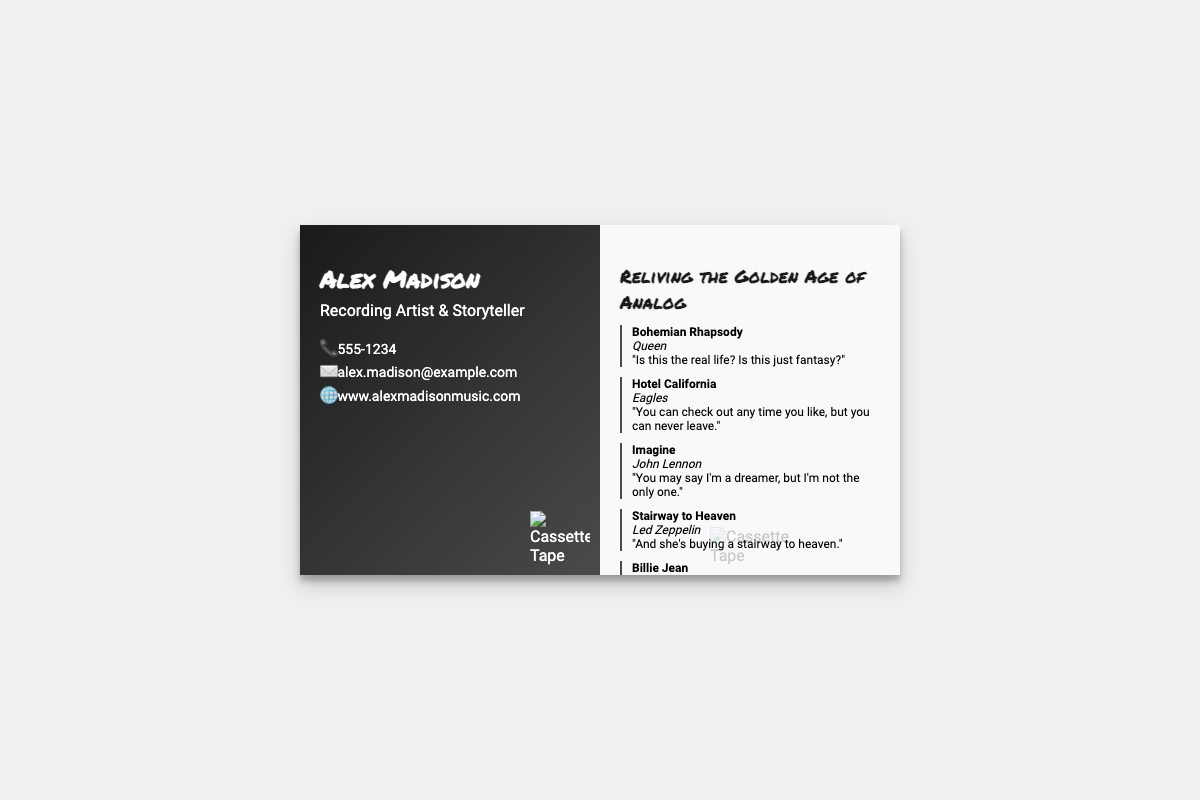What is the name of the recording artist? The name of the recording artist is prominently displayed at the top of the card.
Answer: Alex Madison What is the phone number listed on the business card? The phone number is provided in the contact information section of the card.
Answer: 555-1234 Which song by Queen is quoted on the back? The song title is presented in bold right before the quote on the back of the card.
Answer: Bohemian Rhapsody Who is the artist of "Hotel California"? The artist's name is mentioned directly below the song title in the quote section.
Answer: Eagles What is the main theme of the back side of the business card? The theme is indicated at the top of the back side, summarizing the essence of the information presented.
Answer: Reliving the Golden Age of Analog How many quotes are included on the back of the business card? The document contains a list of quotes, each styled similarly.
Answer: Five What is the background color of the front side of the business card? The front side's background color is part of the visual styling of the card.
Answer: Gradient from dark gray to light gray What type of information is included in the contact info section? The contact info section contains various means of reaching the artist, including phone, email, and website.
Answer: Phone, email, website What style of music does Alex Madison most likely represent based on the quotes? The selected quotes reflect a specific genre popular during a certain era.
Answer: Classic Rock 